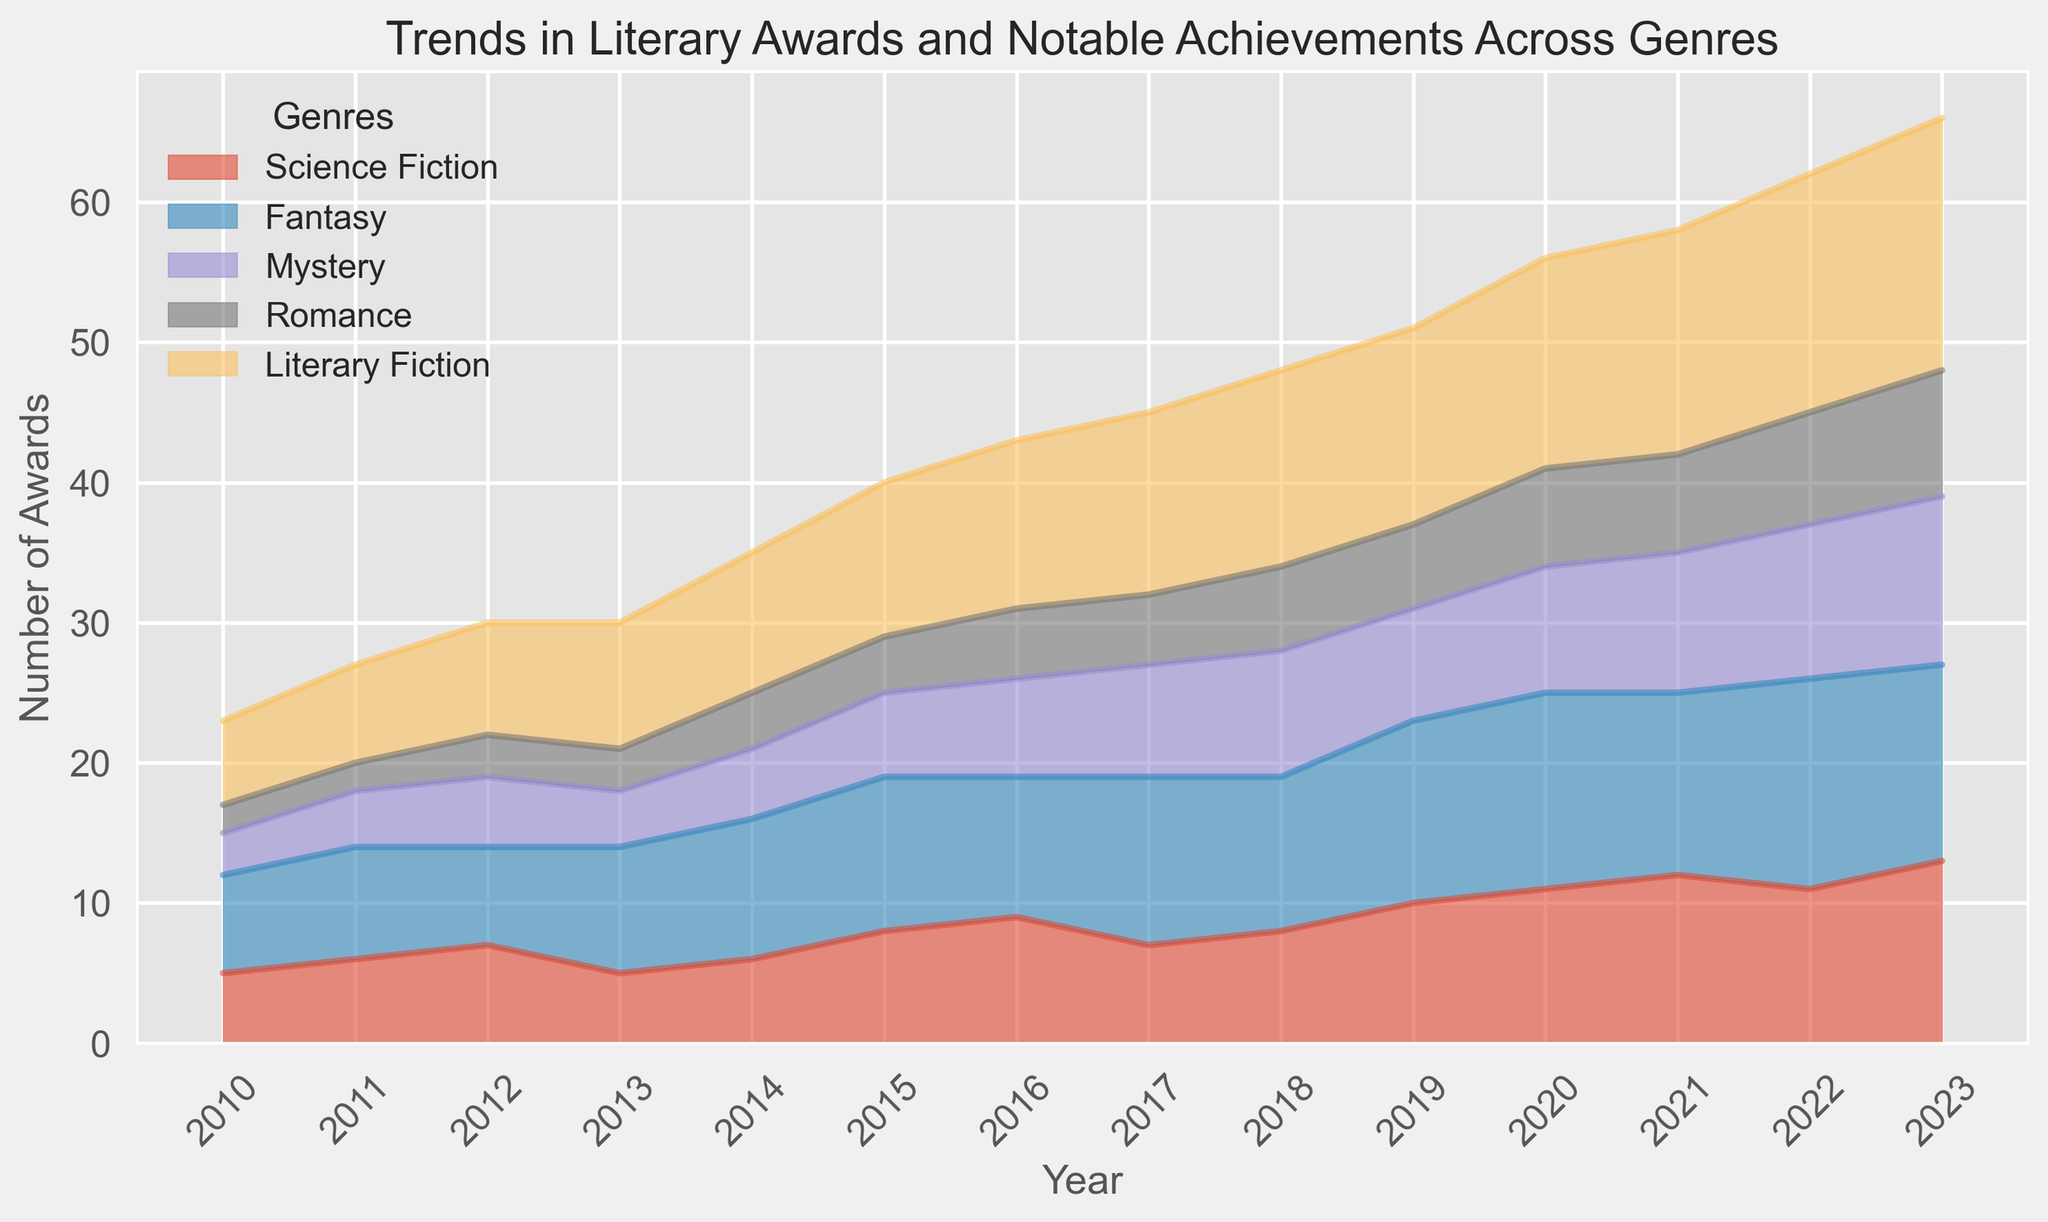Which genre had the most awards in 2023? By inspecting the chart, we see that Literary Fiction had the highest number of awards, reaching 18 in 2023.
Answer: Literary Fiction How did the number of awards in Fantasy compare between 2010 and 2023? In 2010, Fantasy had 7 awards, while in 2023 it had 14 awards. Comparing these, the awards doubled over this period.
Answer: The awards doubled Which genre shows the most steady increase over the period 2010-2023? When looking at the chart, Literary Fiction shows the most consistent increase, growing from 6 awards in 2010 to 18 awards in 2023.
Answer: Literary Fiction How many awards did Romance have in total from 2017 to 2023? Summing up the awards for Romance from 2017 to 2023: 5 + 5 + 6 + 6 + 7 + 7 + 8 + 9 = 53.
Answer: 53 Which year saw the highest number of total awards aggregated across all genres? Aggregating the awards for each year and comparing: 2023 has the highest total: 13 (Science Fiction) + 14 (Fantasy) + 12 (Mystery) + 9 (Romance) + 18 (Literary Fiction) = 66.
Answer: 2023 Compare the trend in awards of Science Fiction and Mystery genres from 2010 to 2022. Science Fiction awards increased consistently from 5 in 2010 to 12 in 2022, while Mystery awards increased from 3 in 2010 to 11 in 2022, showing a somewhat slower but steady increase.
Answer: Science Fiction increased consistently, Mystery increased steadily What is the average number of awards for Fantasy in the first three years (2010-2012)? The awards for Fantasy in 2010-2012 are 7, 8, and 7. The average is calculated as (7 + 8 + 7) / 3 = 22 / 3 = 7.33.
Answer: 7.33 Did any genre experience dips in their number of awards? By inspecting the chart, Science Fiction shows a slight dip in 2013 and 2017, and Literary Fiction remains consistently increasing without dips.
Answer: Science Fiction By how much did the number of Literary Fiction awards grow from 2015 to 2023? The number of Literary Fiction awards grew from 11 in 2015 to 18 in 2023. The increase is 18 - 11 = 7.
Answer: 7 Inspect the visual color areas; which genre has a notable color difference and consistent pattern? Fantasy is represented by a distinct color and shows a noticeable consistent upward pattern, particularly evident in the growing area on the chart visually.
Answer: Fantasy 